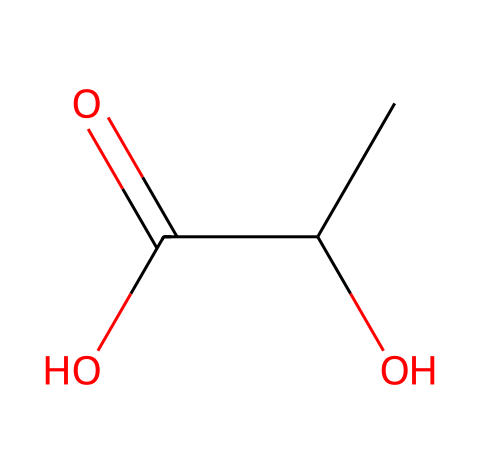What is the chemical name of this compound? The SMILES representation corresponds to lactic acid, which is a common byproduct of intense exercise.
Answer: lactic acid How many carbon atoms are present in lactic acid? By analyzing the SMILES string, we see "CC" indicates two carbon atoms in the main chain, which confirms that there are two carbon atoms in the structure.
Answer: 2 What type of functional groups are present in lactic acid? The structure contains a hydroxyl group (-OH) and a carboxylic acid group (-COOH), which are characteristic functional groups for acids.
Answer: hydroxyl and carboxylic acid What is the total number of hydrogen atoms in lactic acid? In the structure, there are three hydrogen atoms attached to the two carbon atoms, along with one attached to the hydroxyl group, giving a total of four hydrogen atoms.
Answer: 6 Which functional group makes lactic acid an acid? The presence of the carboxylic acid group (-COOH) is what gives lactic acid its acidic properties, allowing it to donate a proton in solution.
Answer: carboxylic acid Is lactic acid considered a strong or weak acid? Lactic acid is known to be a weak acid because it does not completely dissociate in solution.
Answer: weak acid 